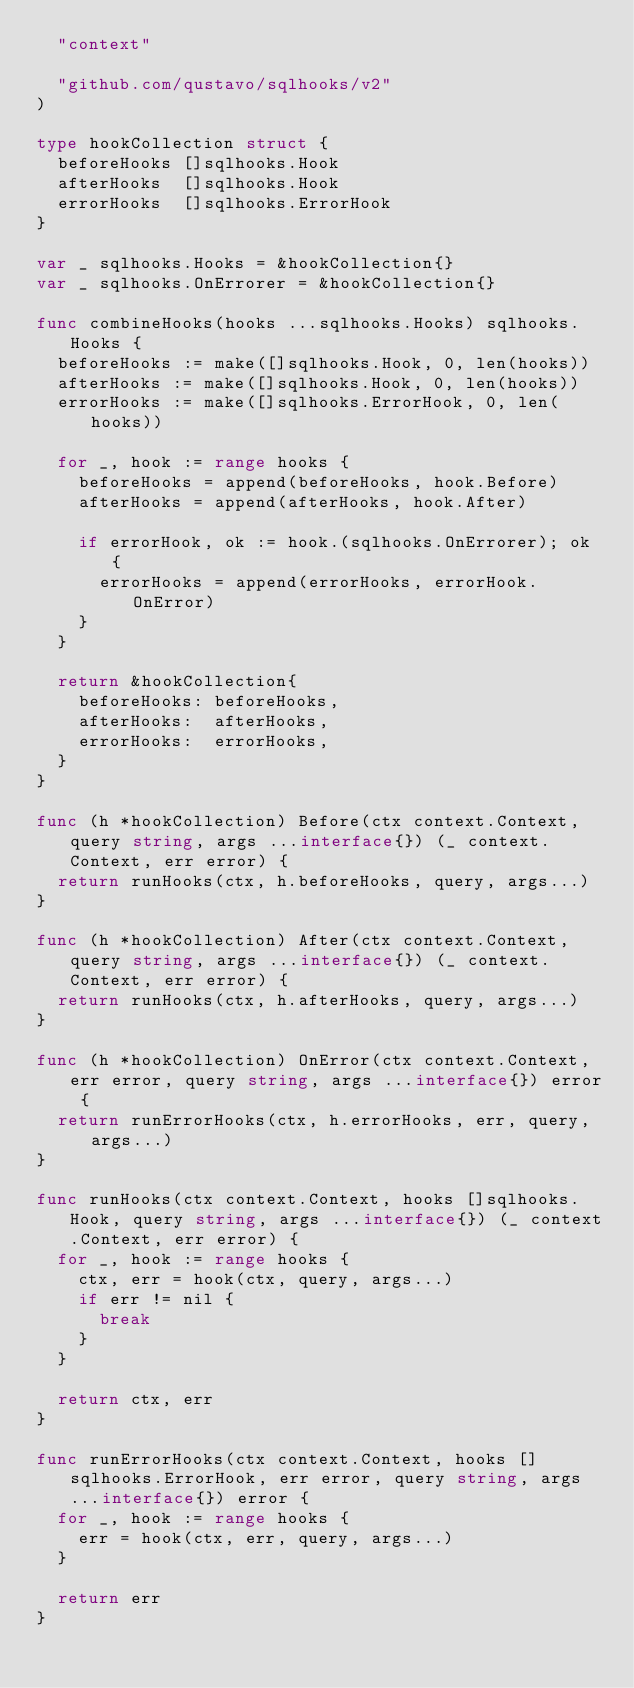<code> <loc_0><loc_0><loc_500><loc_500><_Go_>	"context"

	"github.com/qustavo/sqlhooks/v2"
)

type hookCollection struct {
	beforeHooks []sqlhooks.Hook
	afterHooks  []sqlhooks.Hook
	errorHooks  []sqlhooks.ErrorHook
}

var _ sqlhooks.Hooks = &hookCollection{}
var _ sqlhooks.OnErrorer = &hookCollection{}

func combineHooks(hooks ...sqlhooks.Hooks) sqlhooks.Hooks {
	beforeHooks := make([]sqlhooks.Hook, 0, len(hooks))
	afterHooks := make([]sqlhooks.Hook, 0, len(hooks))
	errorHooks := make([]sqlhooks.ErrorHook, 0, len(hooks))

	for _, hook := range hooks {
		beforeHooks = append(beforeHooks, hook.Before)
		afterHooks = append(afterHooks, hook.After)

		if errorHook, ok := hook.(sqlhooks.OnErrorer); ok {
			errorHooks = append(errorHooks, errorHook.OnError)
		}
	}

	return &hookCollection{
		beforeHooks: beforeHooks,
		afterHooks:  afterHooks,
		errorHooks:  errorHooks,
	}
}

func (h *hookCollection) Before(ctx context.Context, query string, args ...interface{}) (_ context.Context, err error) {
	return runHooks(ctx, h.beforeHooks, query, args...)
}

func (h *hookCollection) After(ctx context.Context, query string, args ...interface{}) (_ context.Context, err error) {
	return runHooks(ctx, h.afterHooks, query, args...)
}

func (h *hookCollection) OnError(ctx context.Context, err error, query string, args ...interface{}) error {
	return runErrorHooks(ctx, h.errorHooks, err, query, args...)
}

func runHooks(ctx context.Context, hooks []sqlhooks.Hook, query string, args ...interface{}) (_ context.Context, err error) {
	for _, hook := range hooks {
		ctx, err = hook(ctx, query, args...)
		if err != nil {
			break
		}
	}

	return ctx, err
}

func runErrorHooks(ctx context.Context, hooks []sqlhooks.ErrorHook, err error, query string, args ...interface{}) error {
	for _, hook := range hooks {
		err = hook(ctx, err, query, args...)
	}

	return err
}
</code> 